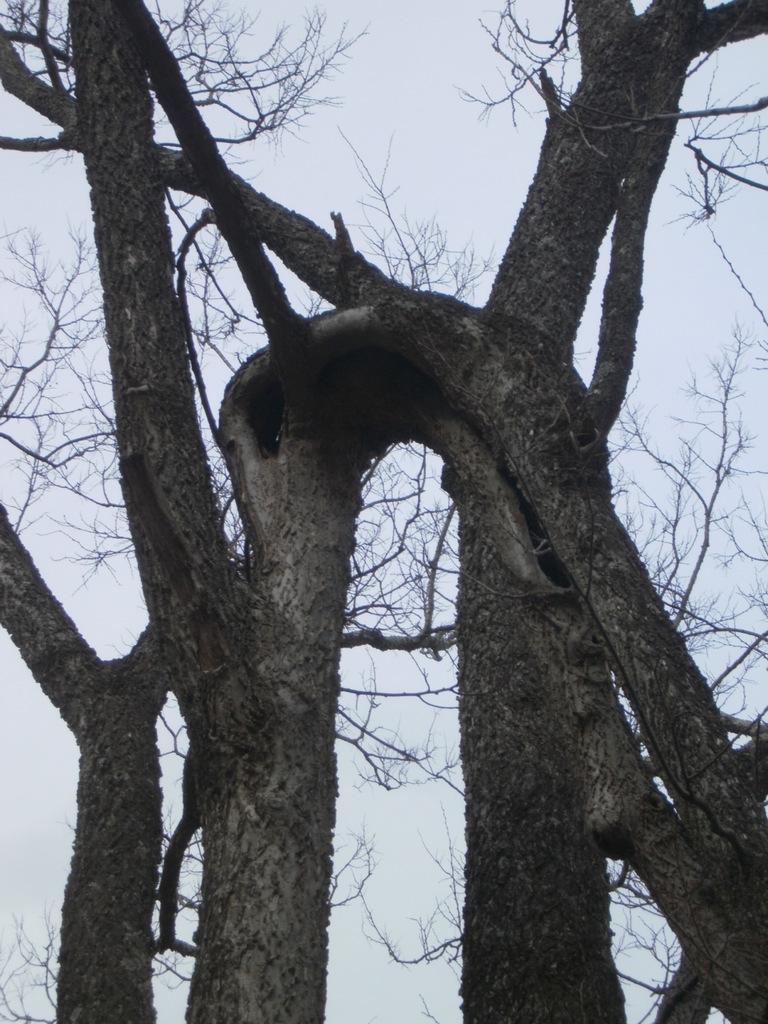In one or two sentences, can you explain what this image depicts? This image is taken outdoors. At the top of the image there is a sky. In the middle of the image there are a few trees. 